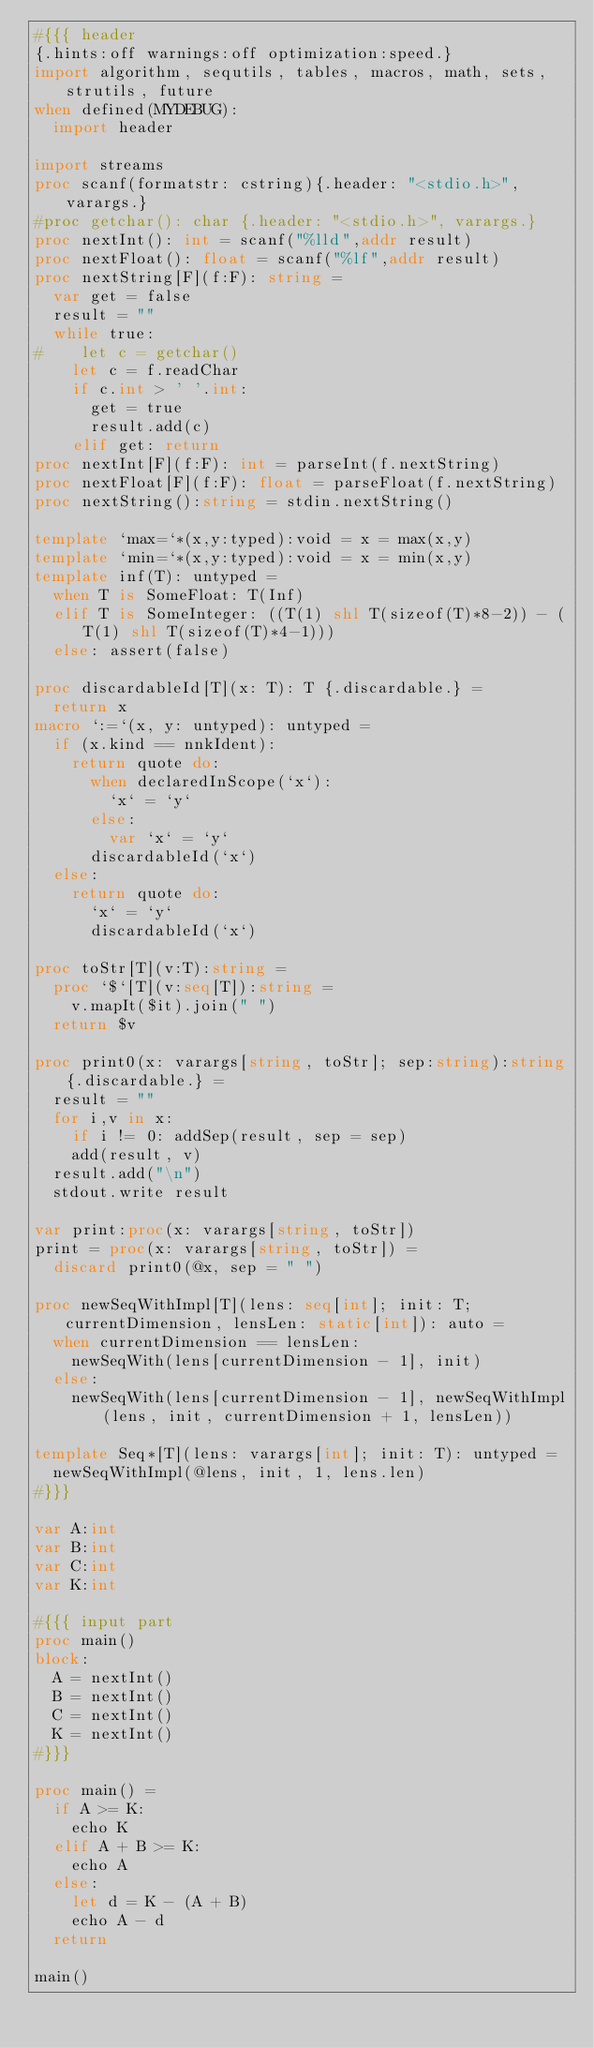Convert code to text. <code><loc_0><loc_0><loc_500><loc_500><_Nim_>#{{{ header
{.hints:off warnings:off optimization:speed.}
import algorithm, sequtils, tables, macros, math, sets, strutils, future
when defined(MYDEBUG):
  import header

import streams
proc scanf(formatstr: cstring){.header: "<stdio.h>", varargs.}
#proc getchar(): char {.header: "<stdio.h>", varargs.}
proc nextInt(): int = scanf("%lld",addr result)
proc nextFloat(): float = scanf("%lf",addr result)
proc nextString[F](f:F): string =
  var get = false
  result = ""
  while true:
#    let c = getchar()
    let c = f.readChar
    if c.int > ' '.int:
      get = true
      result.add(c)
    elif get: return
proc nextInt[F](f:F): int = parseInt(f.nextString)
proc nextFloat[F](f:F): float = parseFloat(f.nextString)
proc nextString():string = stdin.nextString()

template `max=`*(x,y:typed):void = x = max(x,y)
template `min=`*(x,y:typed):void = x = min(x,y)
template inf(T): untyped = 
  when T is SomeFloat: T(Inf)
  elif T is SomeInteger: ((T(1) shl T(sizeof(T)*8-2)) - (T(1) shl T(sizeof(T)*4-1)))
  else: assert(false)

proc discardableId[T](x: T): T {.discardable.} =
  return x
macro `:=`(x, y: untyped): untyped =
  if (x.kind == nnkIdent):
    return quote do:
      when declaredInScope(`x`):
        `x` = `y`
      else:
        var `x` = `y`
      discardableId(`x`)
  else:
    return quote do:
      `x` = `y`
      discardableId(`x`)

proc toStr[T](v:T):string =
  proc `$`[T](v:seq[T]):string =
    v.mapIt($it).join(" ")
  return $v

proc print0(x: varargs[string, toStr]; sep:string):string{.discardable.} =
  result = ""
  for i,v in x:
    if i != 0: addSep(result, sep = sep)
    add(result, v)
  result.add("\n")
  stdout.write result

var print:proc(x: varargs[string, toStr])
print = proc(x: varargs[string, toStr]) =
  discard print0(@x, sep = " ")

proc newSeqWithImpl[T](lens: seq[int]; init: T; currentDimension, lensLen: static[int]): auto =
  when currentDimension == lensLen:
    newSeqWith(lens[currentDimension - 1], init)
  else:
    newSeqWith(lens[currentDimension - 1], newSeqWithImpl(lens, init, currentDimension + 1, lensLen))

template Seq*[T](lens: varargs[int]; init: T): untyped =
  newSeqWithImpl(@lens, init, 1, lens.len)
#}}}

var A:int
var B:int
var C:int
var K:int

#{{{ input part
proc main()
block:
  A = nextInt()
  B = nextInt()
  C = nextInt()
  K = nextInt()
#}}}

proc main() =
  if A >= K:
    echo K
  elif A + B >= K:
    echo A
  else:
    let d = K - (A + B)
    echo A - d
  return

main()
</code> 